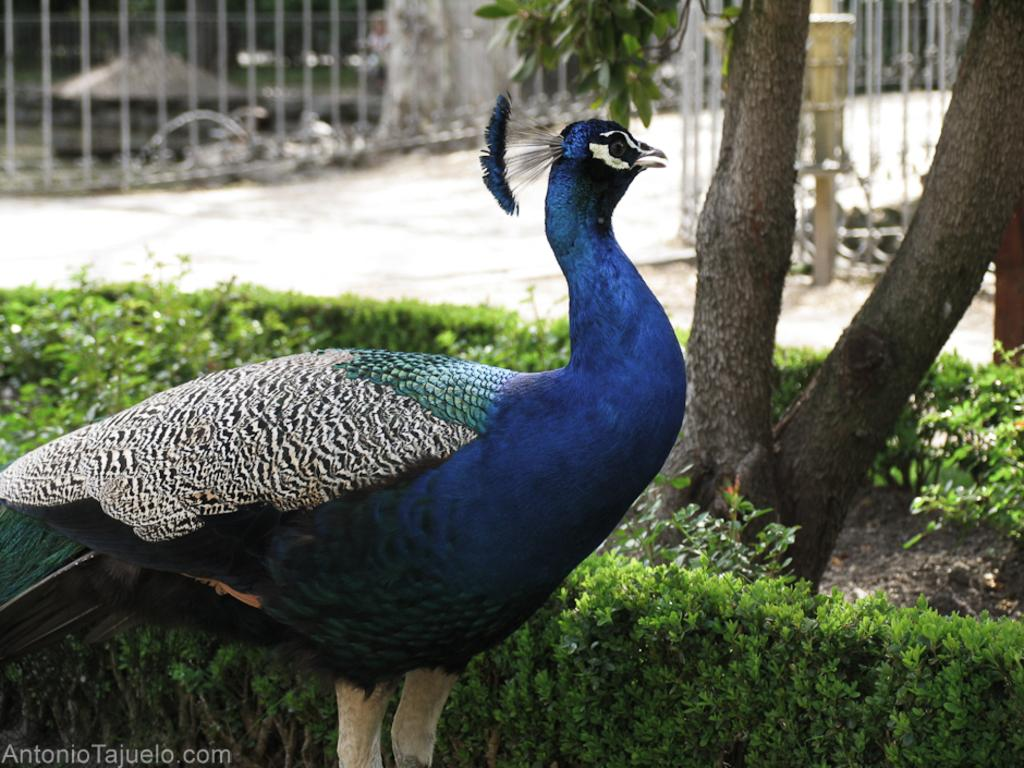What animal is in the foreground of the image? There is a peacock in the foreground of the image. What type of vegetation can be seen in the image? There are plants and a tree in the image. What can be seen in the background of the image? There is a path and a railing in the background of the image. What type of growth can be seen on the peacock's feathers in the image? There is no growth visible on the peacock's feathers in the image. 